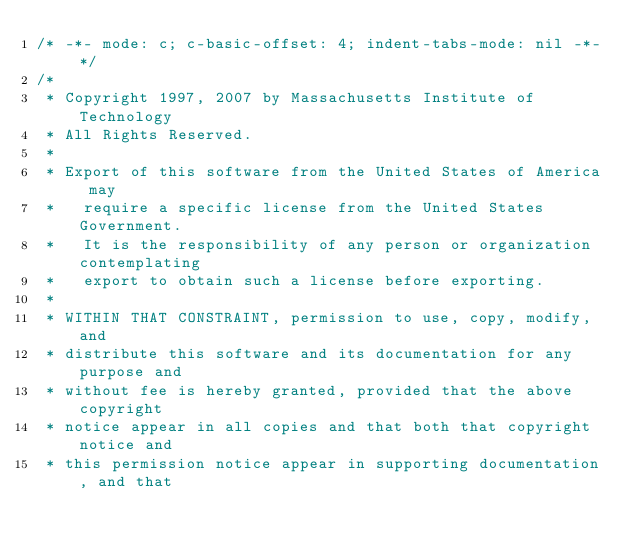Convert code to text. <code><loc_0><loc_0><loc_500><loc_500><_C_>/* -*- mode: c; c-basic-offset: 4; indent-tabs-mode: nil -*- */
/*
 * Copyright 1997, 2007 by Massachusetts Institute of Technology
 * All Rights Reserved.
 *
 * Export of this software from the United States of America may
 *   require a specific license from the United States Government.
 *   It is the responsibility of any person or organization contemplating
 *   export to obtain such a license before exporting.
 *
 * WITHIN THAT CONSTRAINT, permission to use, copy, modify, and
 * distribute this software and its documentation for any purpose and
 * without fee is hereby granted, provided that the above copyright
 * notice appear in all copies and that both that copyright notice and
 * this permission notice appear in supporting documentation, and that</code> 